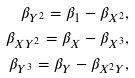Convert formula to latex. <formula><loc_0><loc_0><loc_500><loc_500>\beta _ { Y ^ { 2 } } = \beta _ { 1 } - \beta _ { X ^ { 2 } } , \\ \beta _ { X Y ^ { 2 } } = \beta _ { X } - \beta _ { X ^ { 3 } } , \\ \beta _ { Y ^ { 3 } } = \beta _ { Y } - \beta _ { X ^ { 2 } Y } ,</formula> 